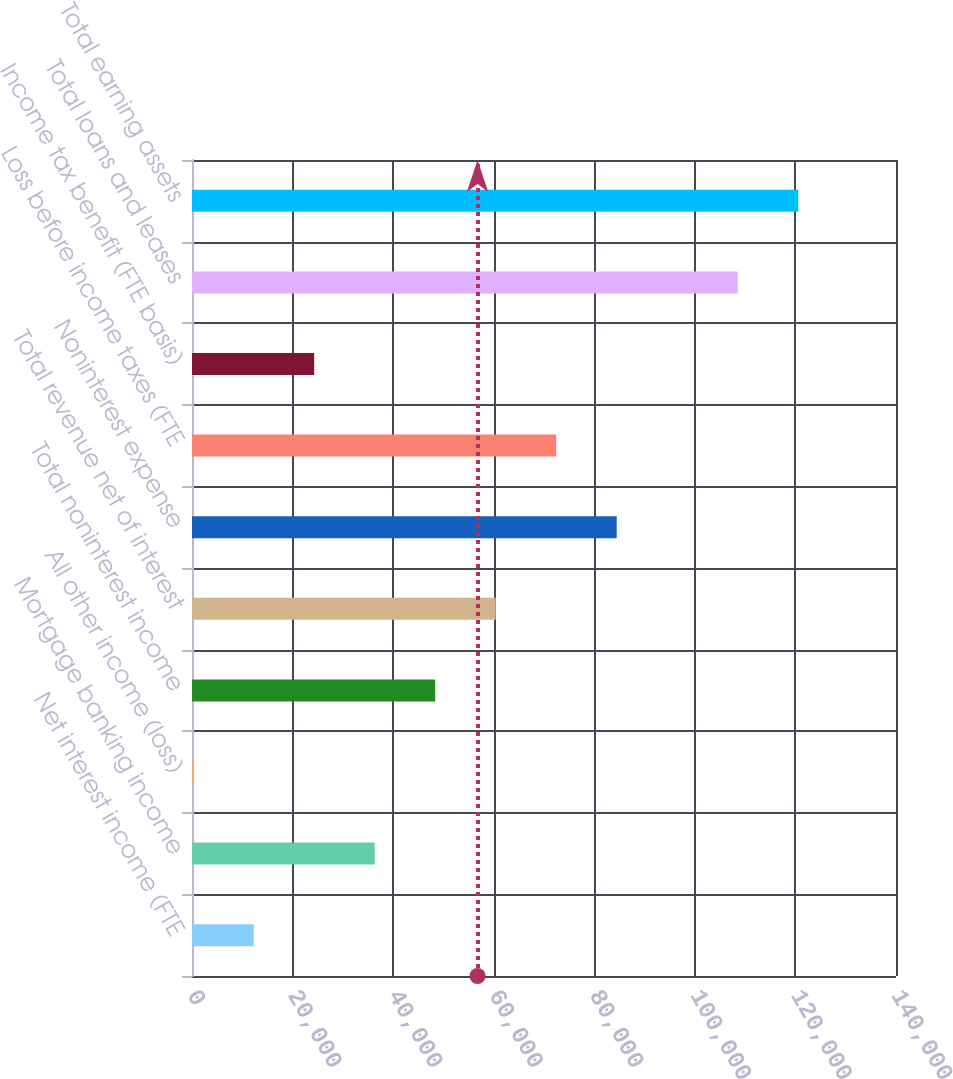Convert chart. <chart><loc_0><loc_0><loc_500><loc_500><bar_chart><fcel>Net interest income (FTE<fcel>Mortgage banking income<fcel>All other income (loss)<fcel>Total noninterest income<fcel>Total revenue net of interest<fcel>Noninterest expense<fcel>Loss before income taxes (FTE<fcel>Income tax benefit (FTE basis)<fcel>Total loans and leases<fcel>Total earning assets<nl><fcel>12271.6<fcel>36334.8<fcel>240<fcel>48366.4<fcel>60398<fcel>84461.2<fcel>72429.6<fcel>24303.2<fcel>108524<fcel>120556<nl></chart> 